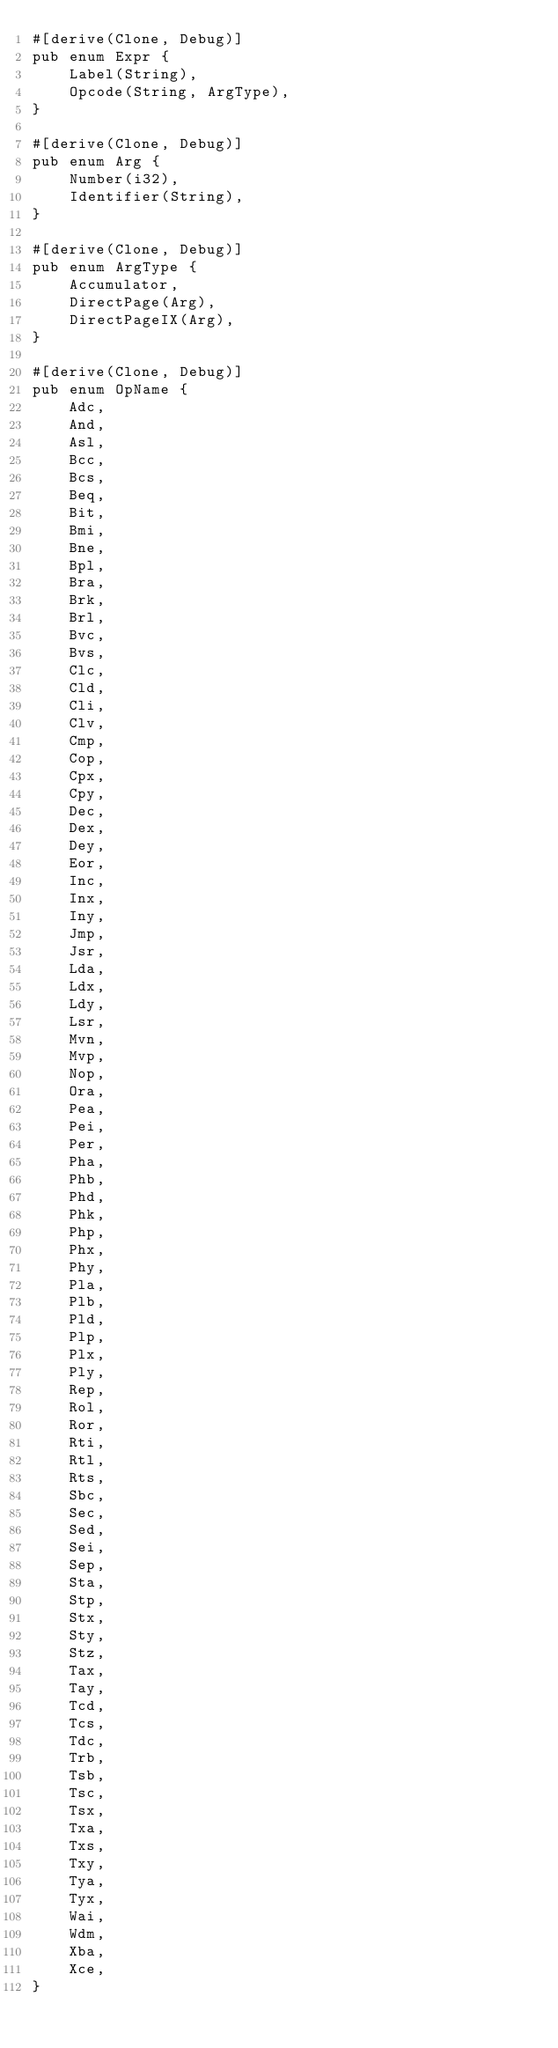Convert code to text. <code><loc_0><loc_0><loc_500><loc_500><_Rust_>#[derive(Clone, Debug)]
pub enum Expr {
    Label(String),
    Opcode(String, ArgType),
}

#[derive(Clone, Debug)]
pub enum Arg {
    Number(i32),
    Identifier(String),
}

#[derive(Clone, Debug)]
pub enum ArgType {
    Accumulator,
    DirectPage(Arg),
    DirectPageIX(Arg),
}

#[derive(Clone, Debug)]
pub enum OpName {
    Adc,
    And,
    Asl,
    Bcc,
    Bcs,
    Beq,
    Bit,
    Bmi,
    Bne,
    Bpl,
    Bra,
    Brk,
    Brl,
    Bvc,
    Bvs,
    Clc,
    Cld,
    Cli,
    Clv,
    Cmp,
    Cop,
    Cpx,
    Cpy,
    Dec,
    Dex,
    Dey,
    Eor,
    Inc,
    Inx,
    Iny,
    Jmp,
    Jsr,
    Lda,
    Ldx,
    Ldy,
    Lsr,
    Mvn,
    Mvp,
    Nop,
    Ora,
    Pea,
    Pei,
    Per,
    Pha,
    Phb,
    Phd,
    Phk,
    Php,
    Phx,
    Phy,
    Pla,
    Plb,
    Pld,
    Plp,
    Plx,
    Ply,
    Rep,
    Rol,
    Ror,
    Rti,
    Rtl,
    Rts,
    Sbc,
    Sec,
    Sed,
    Sei,
    Sep,
    Sta,
    Stp,
    Stx,
    Sty,
    Stz,
    Tax,
    Tay,
    Tcd,
    Tcs,
    Tdc,
    Trb,
    Tsb,
    Tsc,
    Tsx,
    Txa,
    Txs,
    Txy,
    Tya,
    Tyx,
    Wai,
    Wdm,
    Xba,
    Xce,
}</code> 